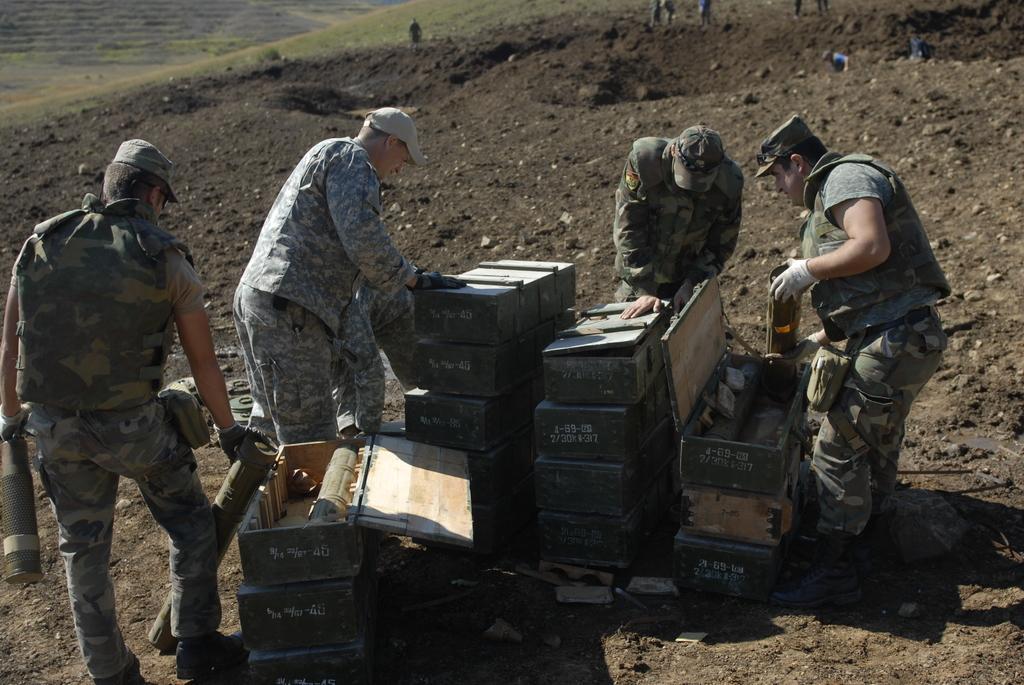Can you describe this image briefly? In the center of the image we can see a few people are standing and they are holding some objects. And we can see they are wearing caps and they are in different costumes. Between them, we can see boxes and a few other objects. In the background we can see the grass, few people are standing and a few other objects. 